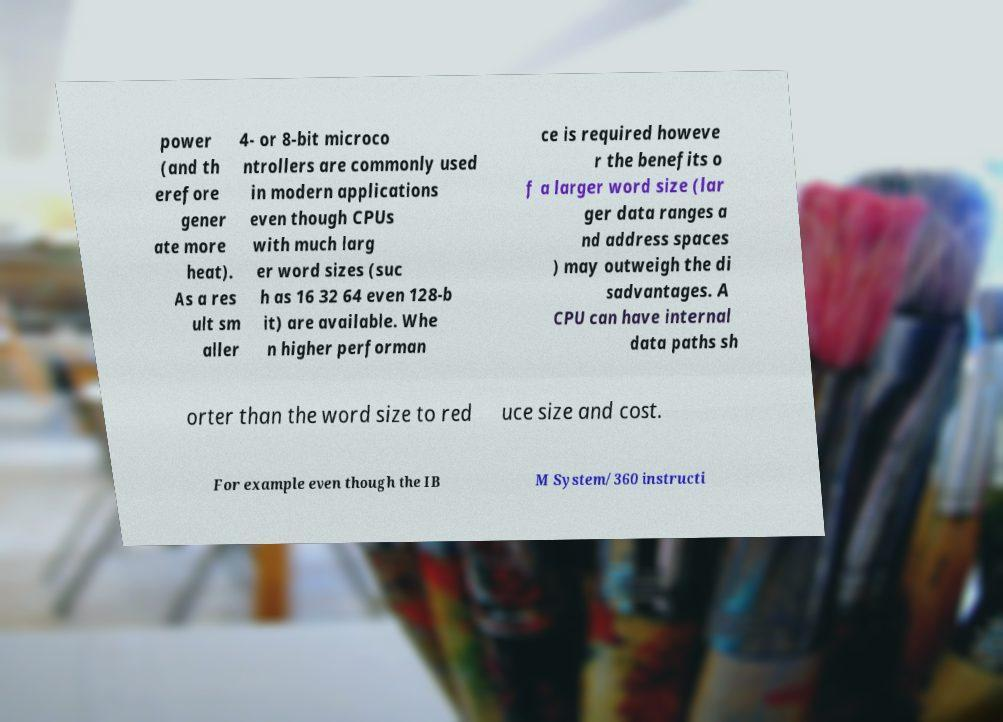Could you assist in decoding the text presented in this image and type it out clearly? power (and th erefore gener ate more heat). As a res ult sm aller 4- or 8-bit microco ntrollers are commonly used in modern applications even though CPUs with much larg er word sizes (suc h as 16 32 64 even 128-b it) are available. Whe n higher performan ce is required howeve r the benefits o f a larger word size (lar ger data ranges a nd address spaces ) may outweigh the di sadvantages. A CPU can have internal data paths sh orter than the word size to red uce size and cost. For example even though the IB M System/360 instructi 